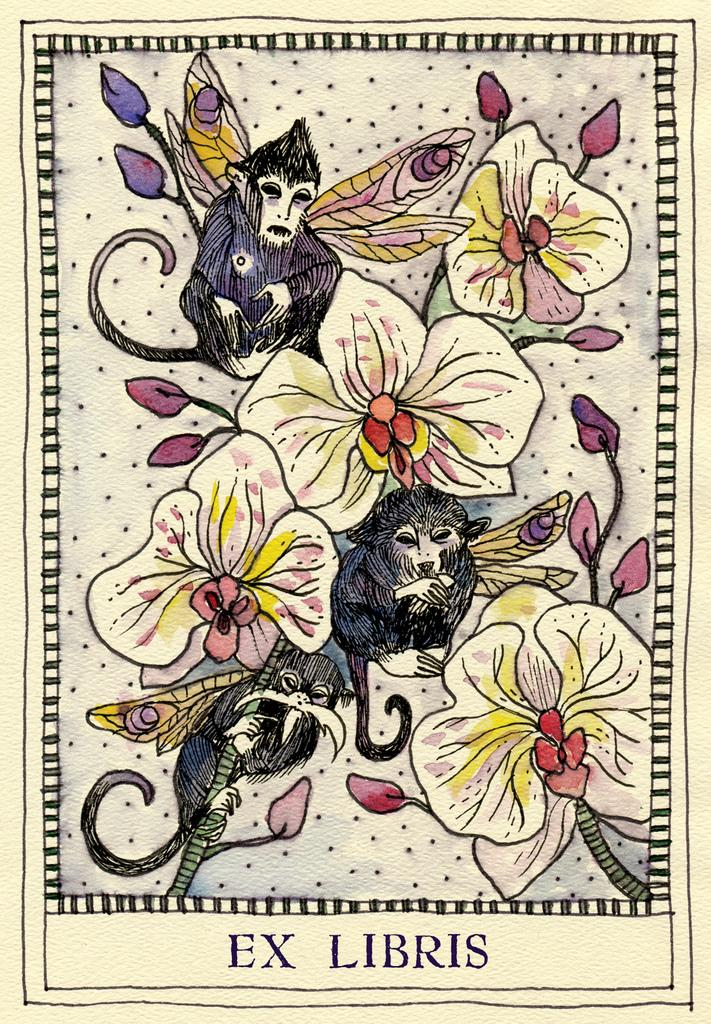What is depicted in the sketch in the image? There is a sketch of flowers and monkeys in the image. What additional feature is present on the sketch? There is text on the sketch. What type of glove is being used by the monkey in the sketch? There is no glove present in the sketch; it only features flowers and monkeys, along with text. 